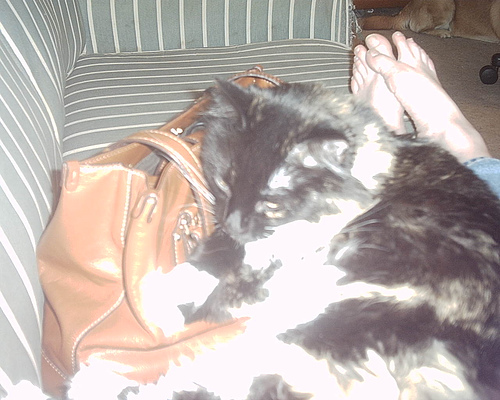What might the cat be dreaming about? The cat might be dreaming about chasing a mouse through a vast field of grass, leaping with joy, and feeling the wind rustle its fur. Perhaps it's dreaming about lounging in a sunny spot, feeling the warmth and comfort as it purrs contentedly. Alternatively, it might be dreaming of a grand adventure, exploring unknown terrains and meeting other playful cats along the way! 